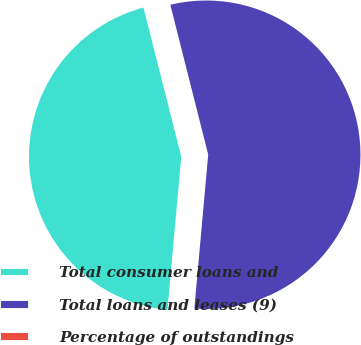Convert chart to OTSL. <chart><loc_0><loc_0><loc_500><loc_500><pie_chart><fcel>Total consumer loans and<fcel>Total loans and leases (9)<fcel>Percentage of outstandings<nl><fcel>44.62%<fcel>55.37%<fcel>0.01%<nl></chart> 